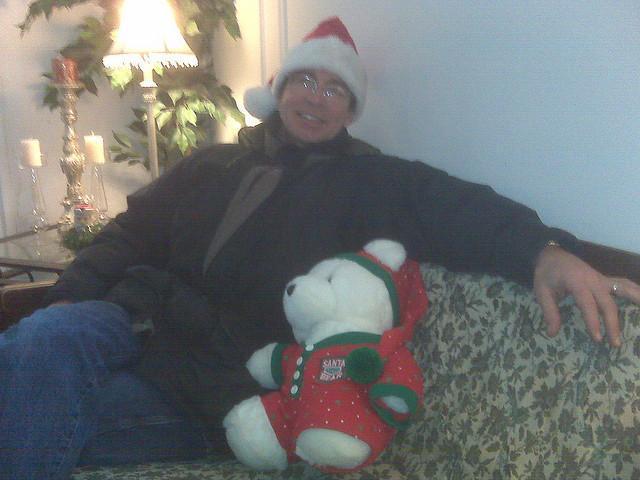Evaluate: Does the caption "The couch is beneath the person." match the image?
Answer yes or no. Yes. Does the description: "The teddy bear is beside the person." accurately reflect the image?
Answer yes or no. Yes. 